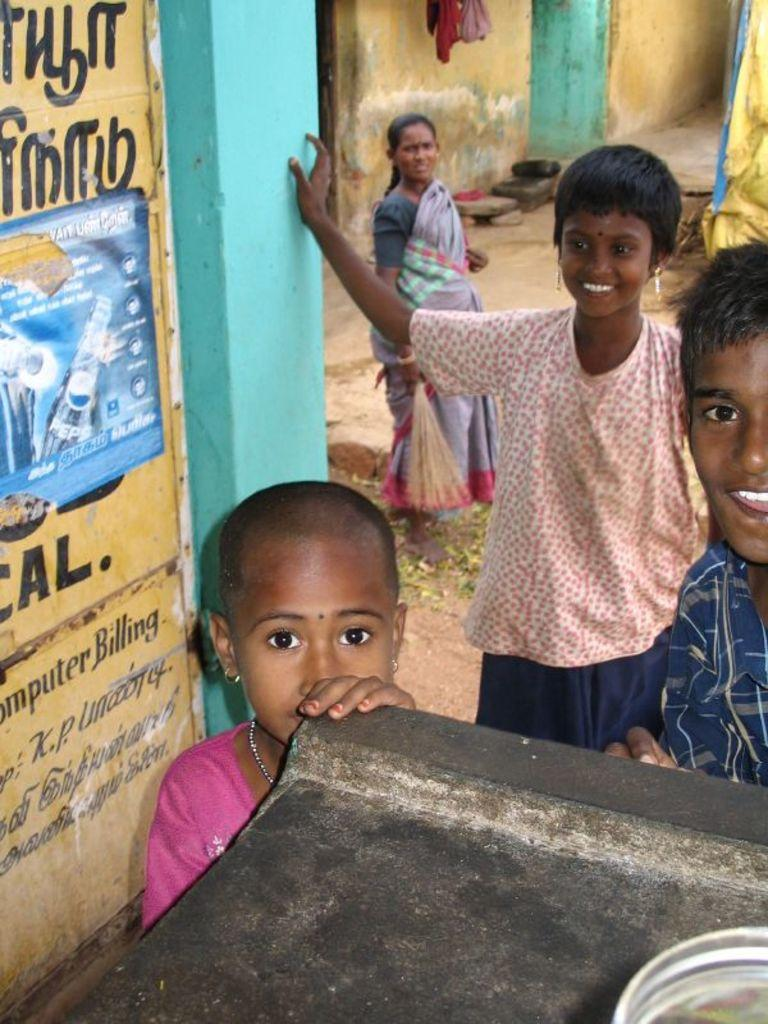How many kids are present in the image? There are three kids standing in the image. Can you describe the woman in the background of the image? The woman in the background of the image is wearing a saree. What is written or depicted on the wall in the image? There is a wall with text in the image. What other object can be seen in the image besides the kids and the woman? There is a poster in the image. What else is visible in the image? There are clothes visible in the image. Can you tell me how many squirrels are climbing on the clothes in the image? There are no squirrels present in the image; only the kids, the woman, the wall with text, the poster, and the clothes are visible. What type of lace is used to decorate the poster in the image? There is no mention of lace in the image; the poster is not described in detail. 